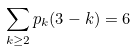Convert formula to latex. <formula><loc_0><loc_0><loc_500><loc_500>\sum _ { k \geq 2 } p _ { k } ( 3 - k ) = 6</formula> 